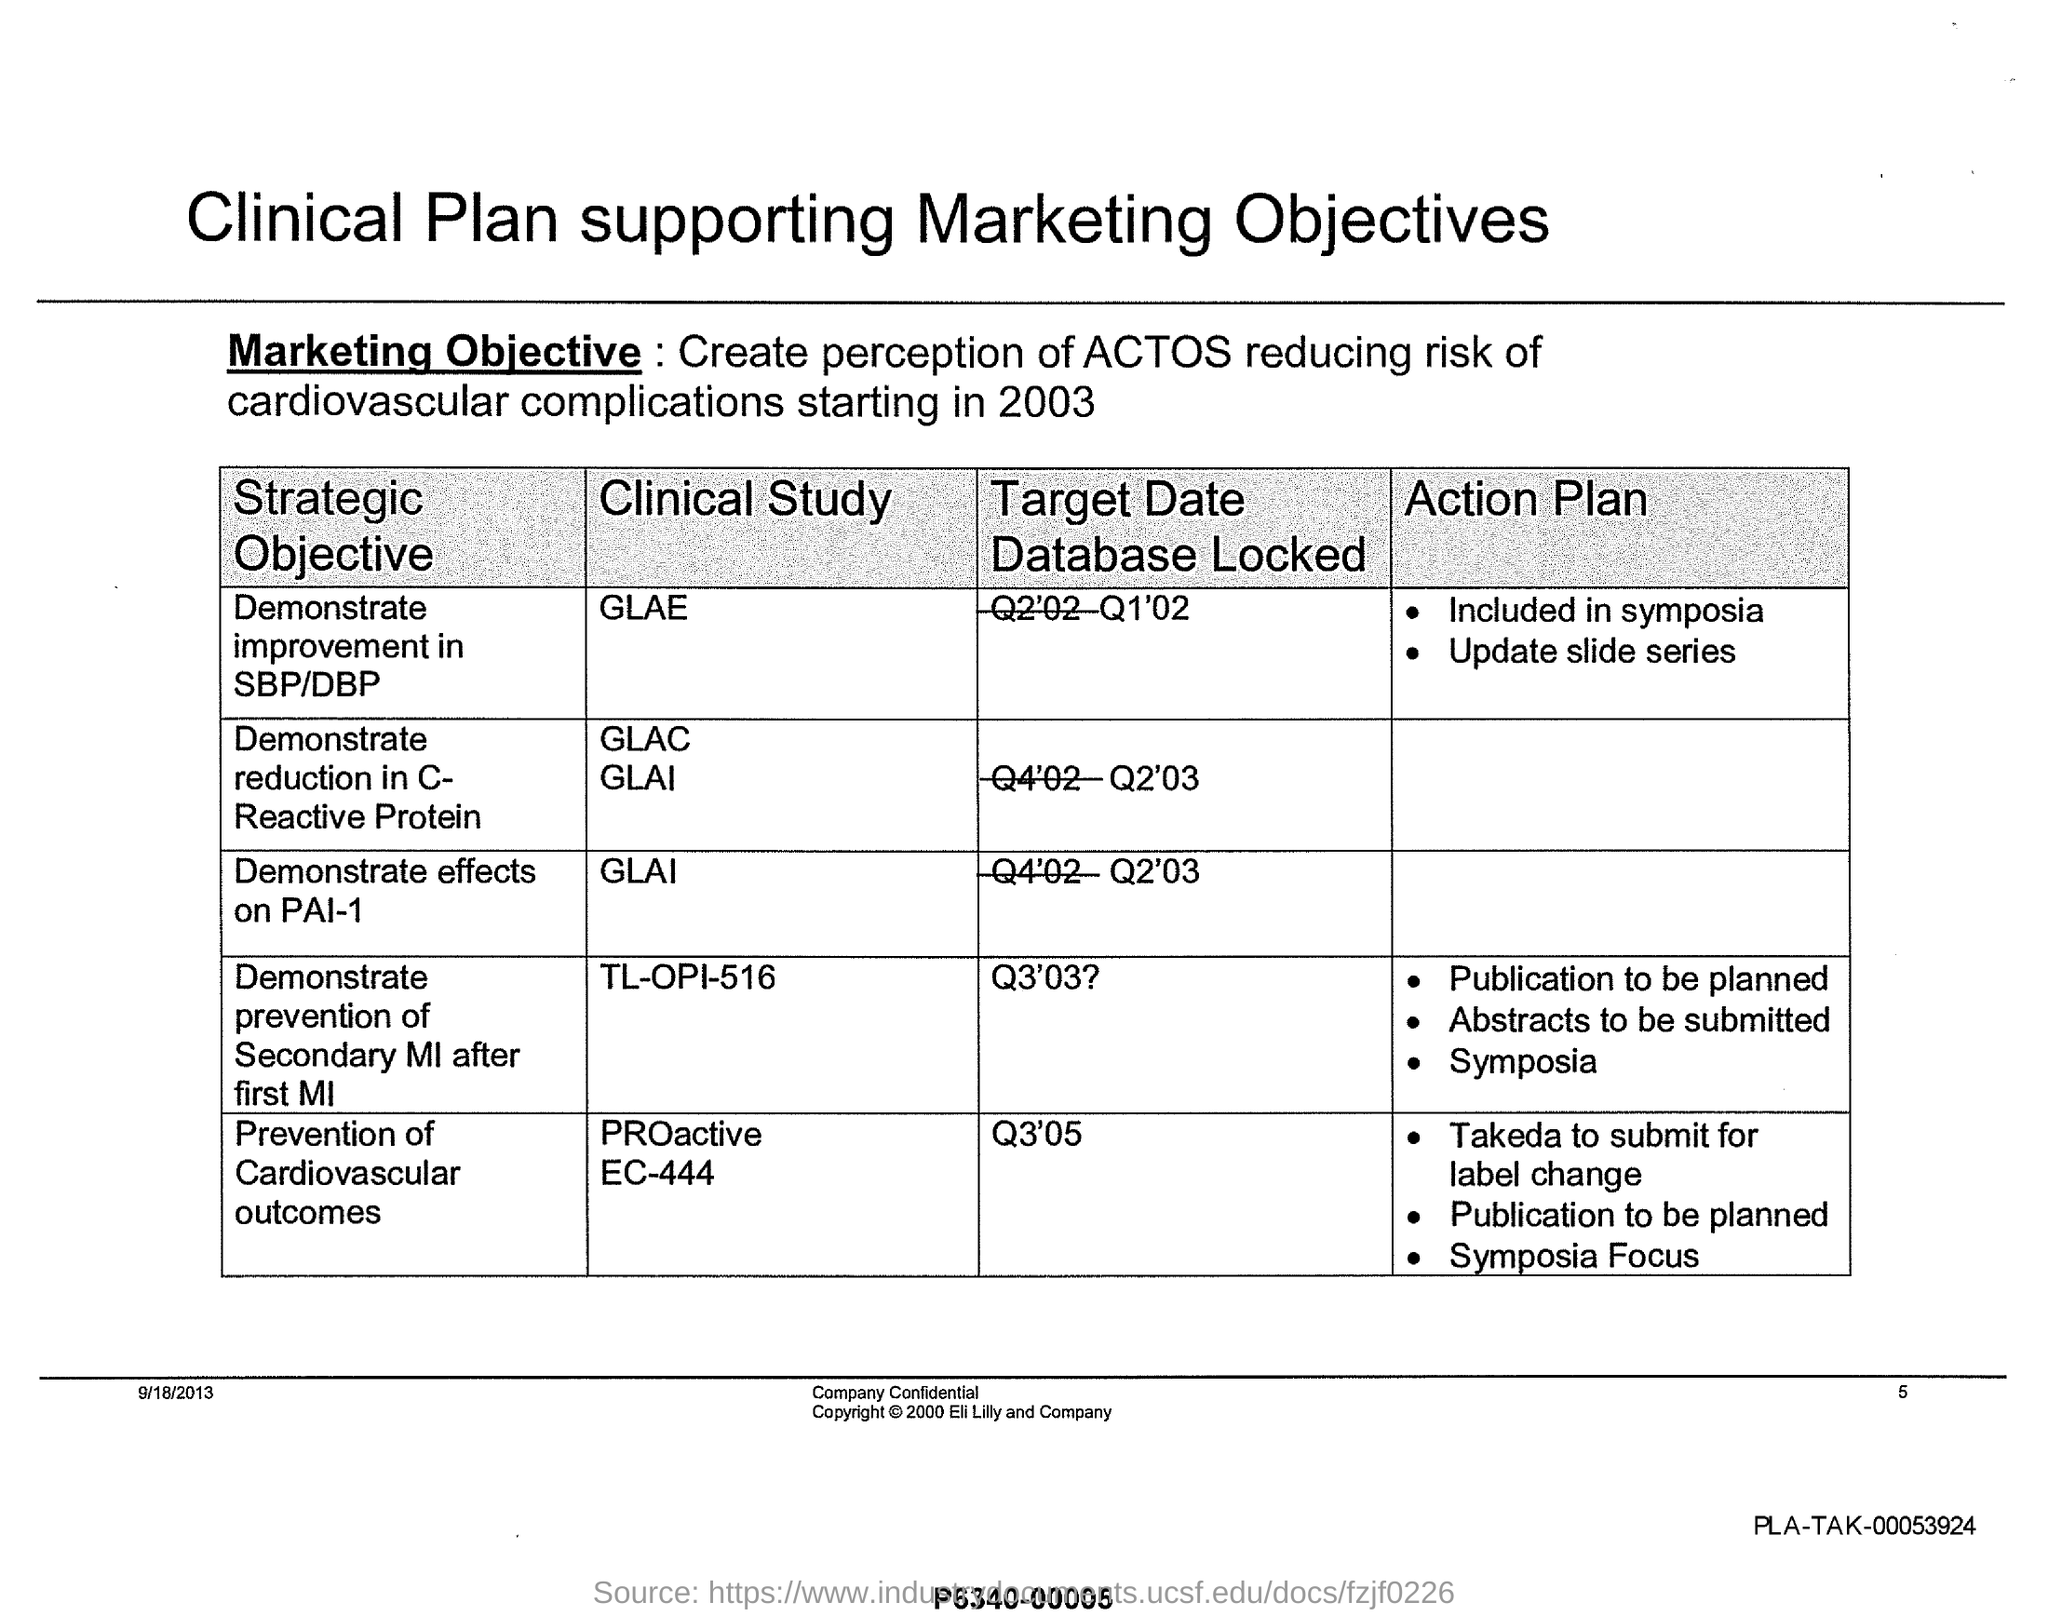What is the marketing objective mentioned in the document?
Your response must be concise. Create perception of ACTOS reducing risk of cardiovascular complications starting in 2003. What is the strategic objective of the Clinical study 'GLAE'?
Give a very brief answer. Demonstrate improvement in sbp/dbp. What is the target date database locked for the clinical study 'GLAI'?
Make the answer very short. Q2'03. What is the strategic oblective of the Clinical study 'TL-OPI-516'?
Keep it short and to the point. Demonstrate prevention of secondary mi after first mi. Which clinical study has target date database locked as Q1'02?
Provide a succinct answer. Glae. 